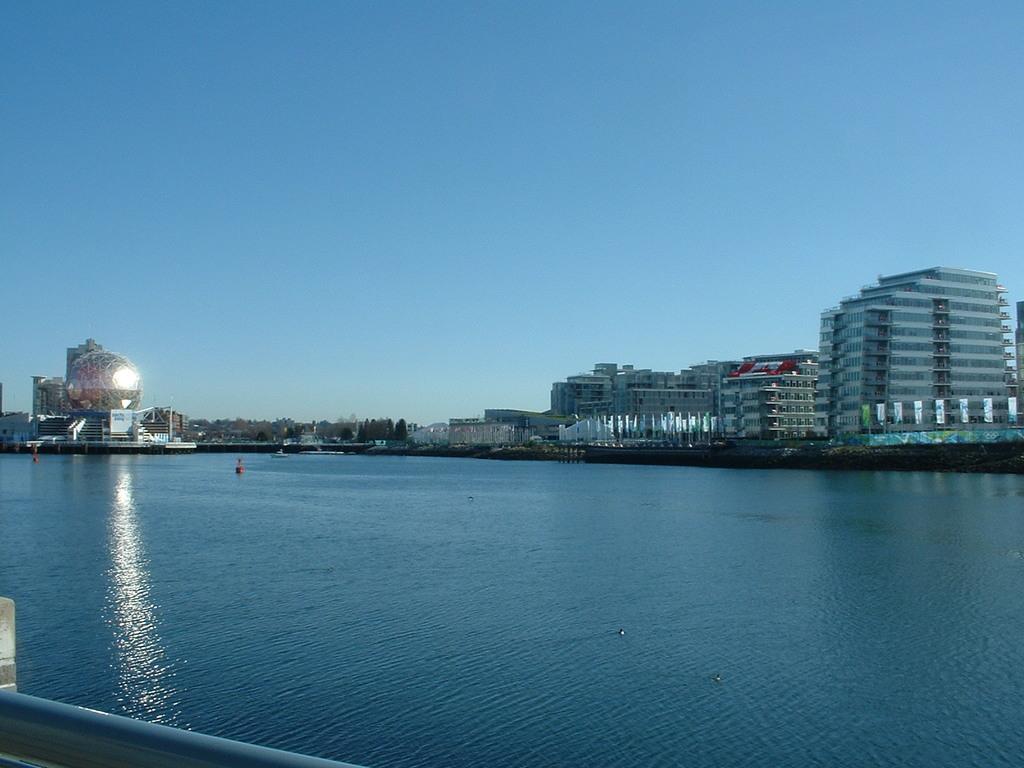Can you describe this image briefly? In the picture there is a river and around the river there are many buildings and houses, on the left side there are plenty of trees in the distance, in the background there is a sky. 